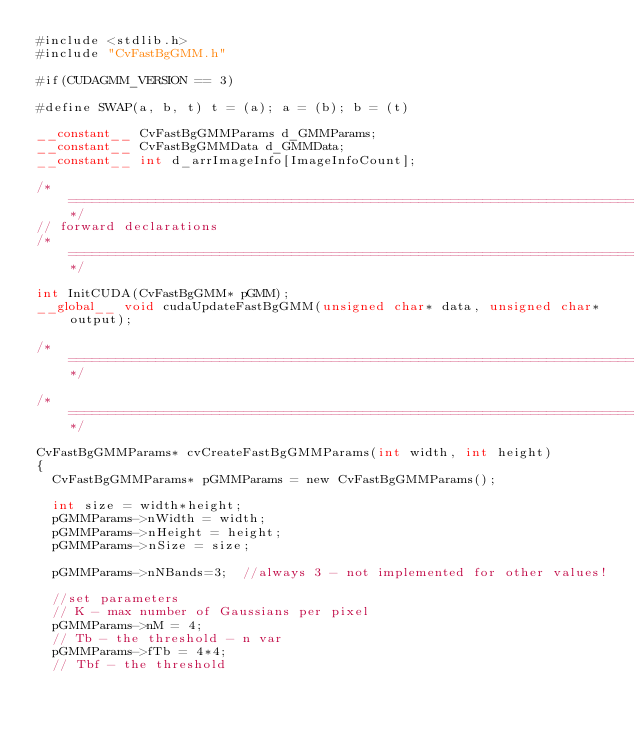Convert code to text. <code><loc_0><loc_0><loc_500><loc_500><_Cuda_>#include <stdlib.h>
#include "CvFastBgGMM.h"

#if(CUDAGMM_VERSION == 3)

#define SWAP(a, b, t)	t = (a); a = (b); b = (t)

__constant__ CvFastBgGMMParams d_GMMParams;
__constant__ CvFastBgGMMData d_GMMData;
__constant__ int d_arrImageInfo[ImageInfoCount];

/*====================================================================================*/
// forward declarations
/*====================================================================================*/

int InitCUDA(CvFastBgGMM* pGMM);
__global__ void cudaUpdateFastBgGMM(unsigned char* data, unsigned char* output);

/*====================================================================================*/

/*====================================================================================*/

CvFastBgGMMParams* cvCreateFastBgGMMParams(int width, int height)
{
	CvFastBgGMMParams* pGMMParams = new CvFastBgGMMParams();

	int size = width*height;
	pGMMParams->nWidth = width;
	pGMMParams->nHeight = height;
	pGMMParams->nSize = size;

	pGMMParams->nNBands=3;	//always 3 - not implemented for other values!

	//set parameters
	// K - max number of Gaussians per pixel
	pGMMParams->nM = 4;			
	// Tb - the threshold - n var
	pGMMParams->fTb = 4*4;
	// Tbf - the threshold</code> 